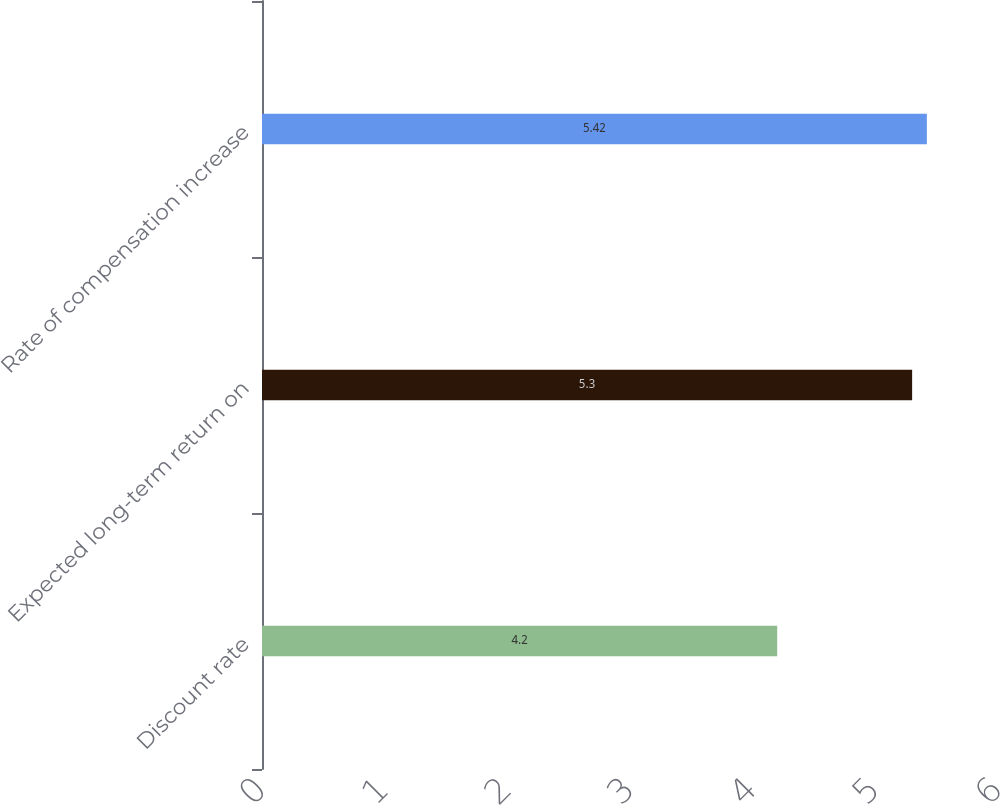Convert chart to OTSL. <chart><loc_0><loc_0><loc_500><loc_500><bar_chart><fcel>Discount rate<fcel>Expected long-term return on<fcel>Rate of compensation increase<nl><fcel>4.2<fcel>5.3<fcel>5.42<nl></chart> 